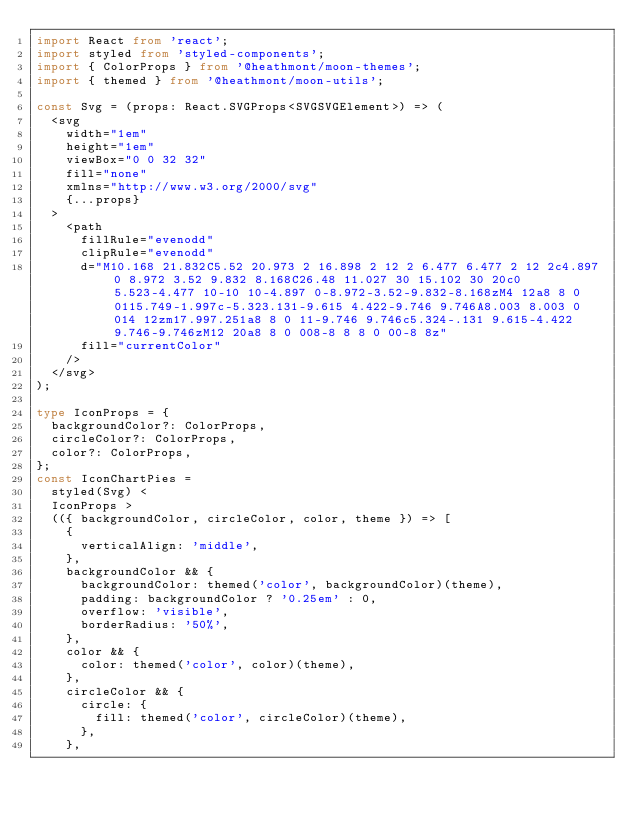Convert code to text. <code><loc_0><loc_0><loc_500><loc_500><_TypeScript_>import React from 'react';
import styled from 'styled-components';
import { ColorProps } from '@heathmont/moon-themes';
import { themed } from '@heathmont/moon-utils';

const Svg = (props: React.SVGProps<SVGSVGElement>) => (
  <svg
    width="1em"
    height="1em"
    viewBox="0 0 32 32"
    fill="none"
    xmlns="http://www.w3.org/2000/svg"
    {...props}
  >
    <path
      fillRule="evenodd"
      clipRule="evenodd"
      d="M10.168 21.832C5.52 20.973 2 16.898 2 12 2 6.477 6.477 2 12 2c4.897 0 8.972 3.52 9.832 8.168C26.48 11.027 30 15.102 30 20c0 5.523-4.477 10-10 10-4.897 0-8.972-3.52-9.832-8.168zM4 12a8 8 0 0115.749-1.997c-5.323.131-9.615 4.422-9.746 9.746A8.003 8.003 0 014 12zm17.997.251a8 8 0 11-9.746 9.746c5.324-.131 9.615-4.422 9.746-9.746zM12 20a8 8 0 008-8 8 8 0 00-8 8z"
      fill="currentColor"
    />
  </svg>
);

type IconProps = {
  backgroundColor?: ColorProps,
  circleColor?: ColorProps,
  color?: ColorProps,
};
const IconChartPies =
  styled(Svg) <
  IconProps >
  (({ backgroundColor, circleColor, color, theme }) => [
    {
      verticalAlign: 'middle',
    },
    backgroundColor && {
      backgroundColor: themed('color', backgroundColor)(theme),
      padding: backgroundColor ? '0.25em' : 0,
      overflow: 'visible',
      borderRadius: '50%',
    },
    color && {
      color: themed('color', color)(theme),
    },
    circleColor && {
      circle: {
        fill: themed('color', circleColor)(theme),
      },
    },</code> 